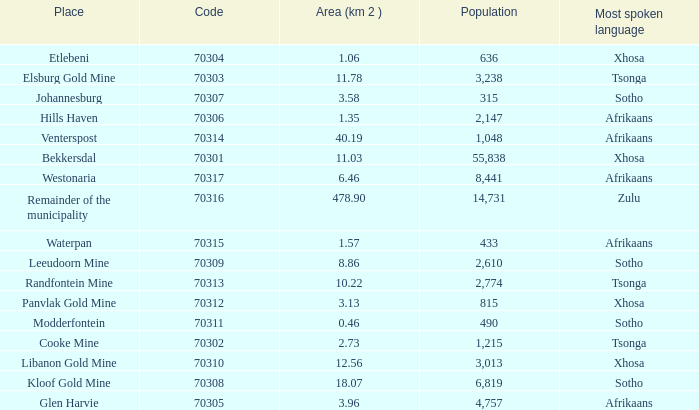What is the low code for glen harvie with a population greater than 2,774? 70305.0. 